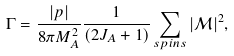Convert formula to latex. <formula><loc_0><loc_0><loc_500><loc_500>\Gamma = \frac { | p | } { 8 \pi M _ { A } ^ { 2 } } \frac { 1 } { ( 2 J _ { A } + 1 ) } \sum _ { s p i n s } | \mathcal { M } | ^ { 2 } ,</formula> 